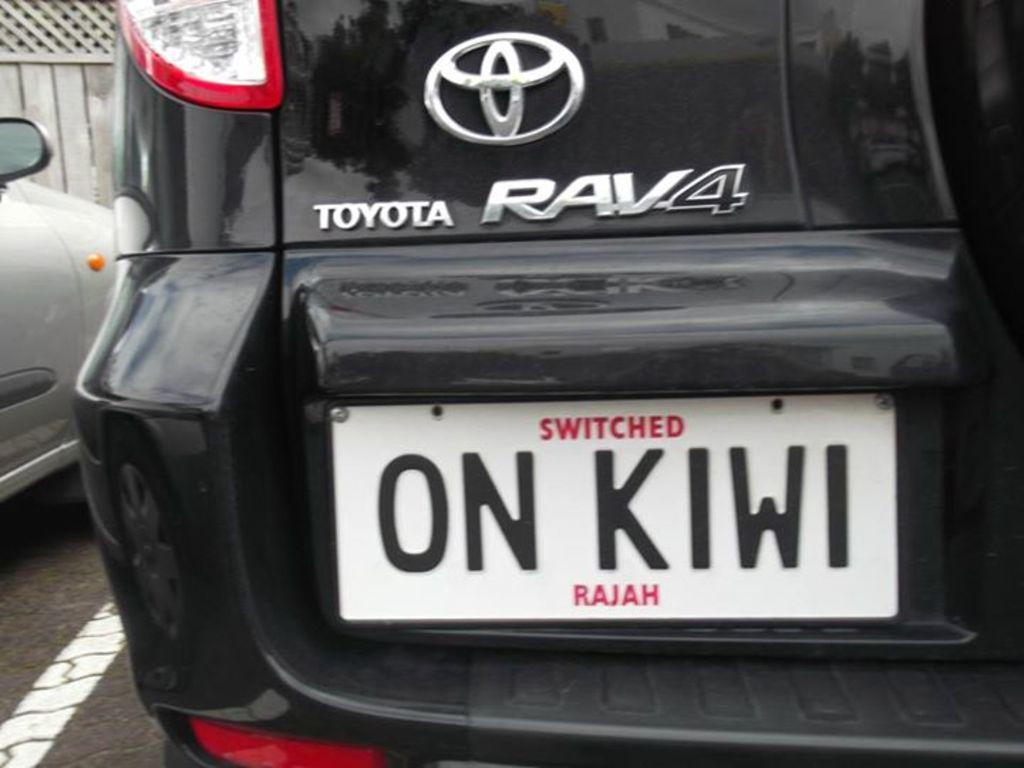<image>
Provide a brief description of the given image. A black Toyota RAV4 with the license plate ON KIWI is parked. 